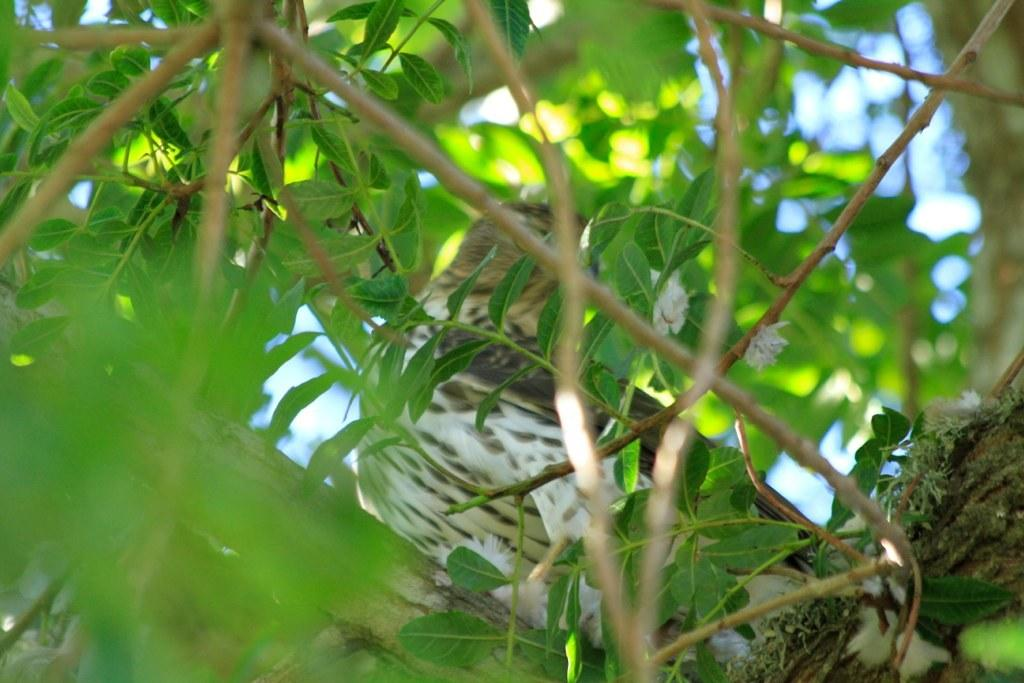What type of animal can be seen in the image? There is a bird in the image. Where is the bird located? The bird is on a tree. What can be seen in the foreground of the image? Leaves and stems are visible in the foreground. What type of furniture is visible in the image? There is no furniture present in the image; it features a bird on a tree with leaves and stems in the foreground. 